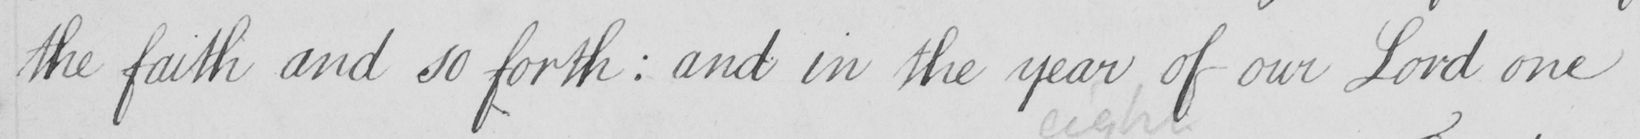Transcribe the text shown in this historical manuscript line. the faith and so forth :  and in the year of our Lord one 